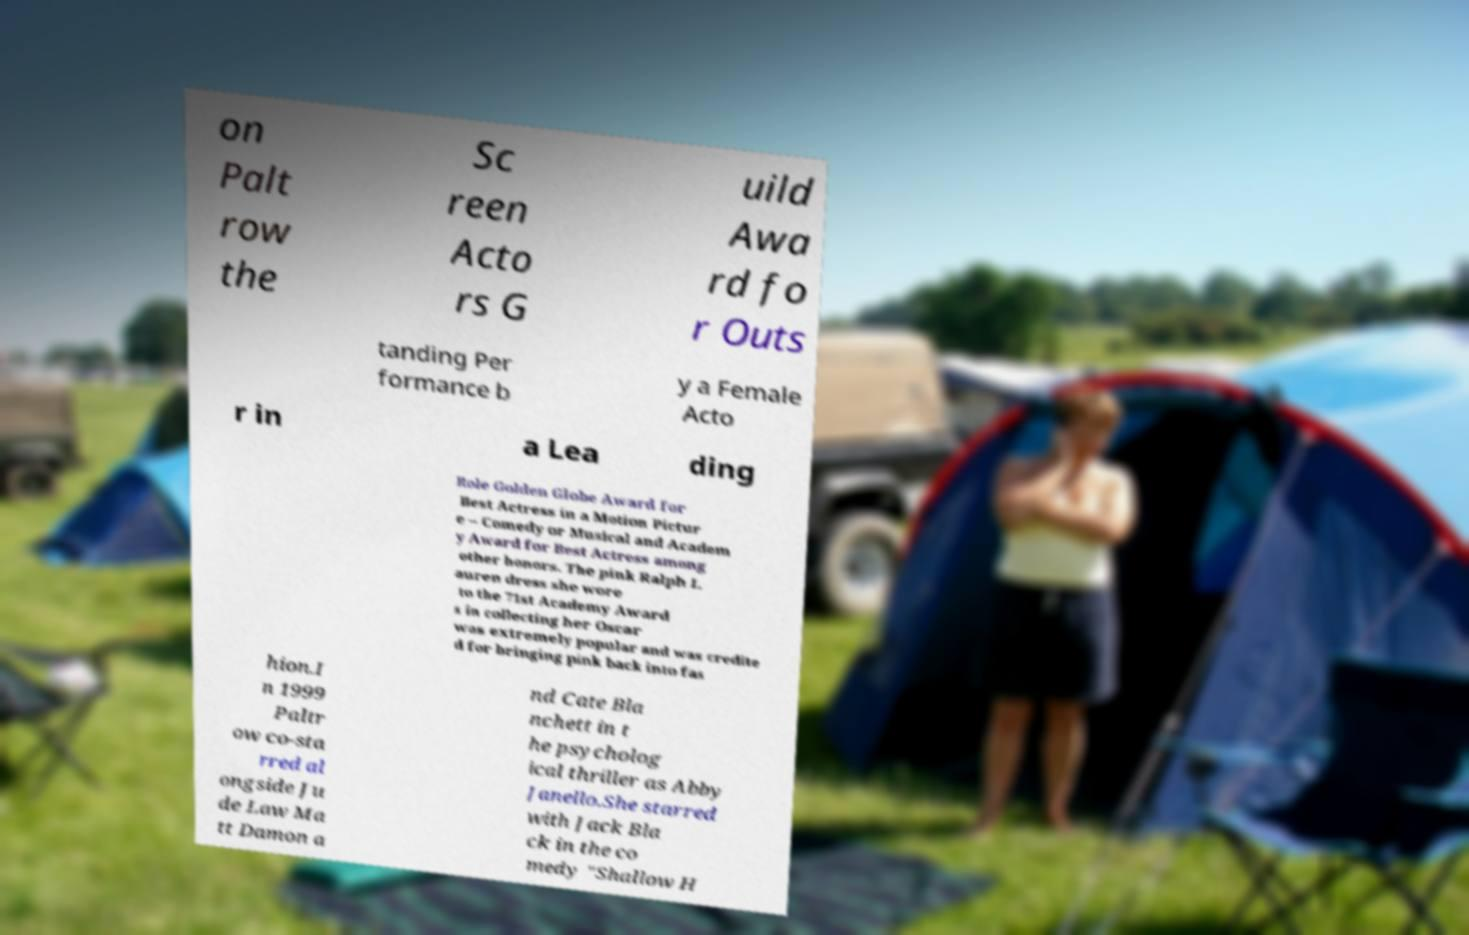I need the written content from this picture converted into text. Can you do that? on Palt row the Sc reen Acto rs G uild Awa rd fo r Outs tanding Per formance b y a Female Acto r in a Lea ding Role Golden Globe Award for Best Actress in a Motion Pictur e – Comedy or Musical and Academ y Award for Best Actress among other honors. The pink Ralph L auren dress she wore to the 71st Academy Award s in collecting her Oscar was extremely popular and was credite d for bringing pink back into fas hion.I n 1999 Paltr ow co-sta rred al ongside Ju de Law Ma tt Damon a nd Cate Bla nchett in t he psycholog ical thriller as Abby Janello.She starred with Jack Bla ck in the co medy "Shallow H 